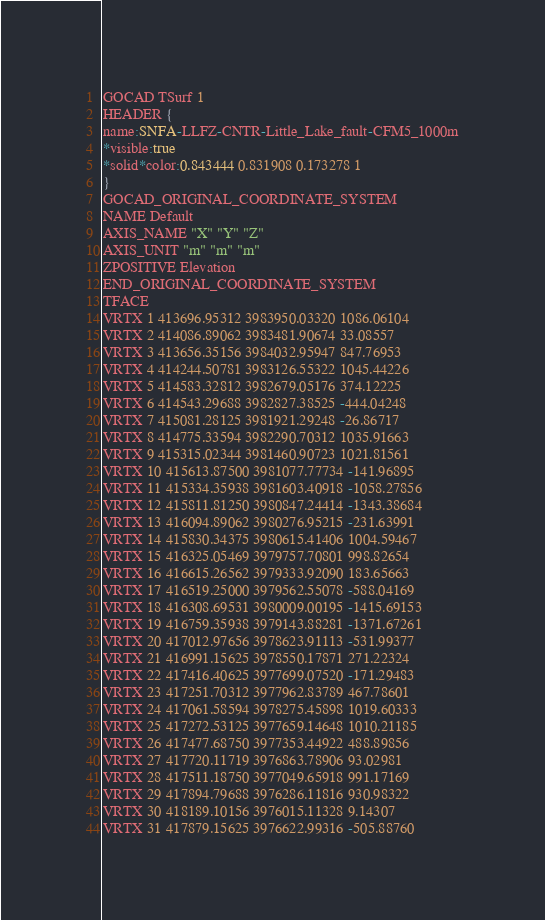<code> <loc_0><loc_0><loc_500><loc_500><_TypeScript_>GOCAD TSurf 1
HEADER {
name:SNFA-LLFZ-CNTR-Little_Lake_fault-CFM5_1000m
*visible:true
*solid*color:0.843444 0.831908 0.173278 1
}
GOCAD_ORIGINAL_COORDINATE_SYSTEM
NAME Default
AXIS_NAME "X" "Y" "Z"
AXIS_UNIT "m" "m" "m"
ZPOSITIVE Elevation
END_ORIGINAL_COORDINATE_SYSTEM
TFACE
VRTX 1 413696.95312 3983950.03320 1086.06104
VRTX 2 414086.89062 3983481.90674 33.08557
VRTX 3 413656.35156 3984032.95947 847.76953
VRTX 4 414244.50781 3983126.55322 1045.44226
VRTX 5 414583.32812 3982679.05176 374.12225
VRTX 6 414543.29688 3982827.38525 -444.04248
VRTX 7 415081.28125 3981921.29248 -26.86717
VRTX 8 414775.33594 3982290.70312 1035.91663
VRTX 9 415315.02344 3981460.90723 1021.81561
VRTX 10 415613.87500 3981077.77734 -141.96895
VRTX 11 415334.35938 3981603.40918 -1058.27856
VRTX 12 415811.81250 3980847.24414 -1343.38684
VRTX 13 416094.89062 3980276.95215 -231.63991
VRTX 14 415830.34375 3980615.41406 1004.59467
VRTX 15 416325.05469 3979757.70801 998.82654
VRTX 16 416615.26562 3979333.92090 183.65663
VRTX 17 416519.25000 3979562.55078 -588.04169
VRTX 18 416308.69531 3980009.00195 -1415.69153
VRTX 19 416759.35938 3979143.88281 -1371.67261
VRTX 20 417012.97656 3978623.91113 -531.99377
VRTX 21 416991.15625 3978550.17871 271.22324
VRTX 22 417416.40625 3977699.07520 -171.29483
VRTX 23 417251.70312 3977962.83789 467.78601
VRTX 24 417061.58594 3978275.45898 1019.60333
VRTX 25 417272.53125 3977659.14648 1010.21185
VRTX 26 417477.68750 3977353.44922 488.89856
VRTX 27 417720.11719 3976863.78906 93.02981
VRTX 28 417511.18750 3977049.65918 991.17169
VRTX 29 417894.79688 3976286.11816 930.98322
VRTX 30 418189.10156 3976015.11328 9.14307
VRTX 31 417879.15625 3976622.99316 -505.88760</code> 